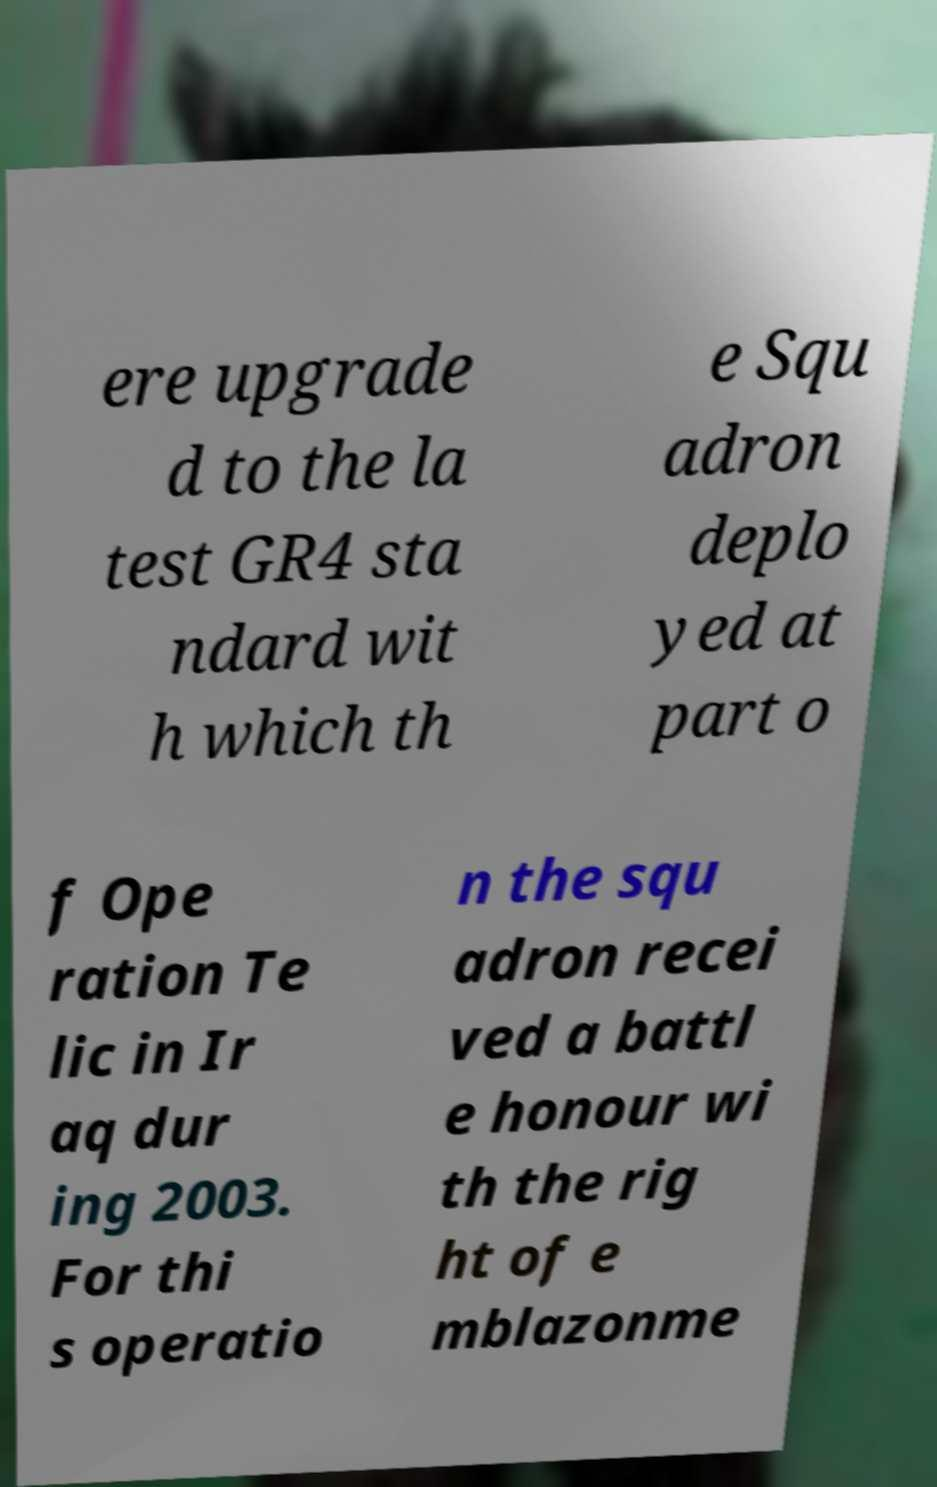Could you extract and type out the text from this image? ere upgrade d to the la test GR4 sta ndard wit h which th e Squ adron deplo yed at part o f Ope ration Te lic in Ir aq dur ing 2003. For thi s operatio n the squ adron recei ved a battl e honour wi th the rig ht of e mblazonme 